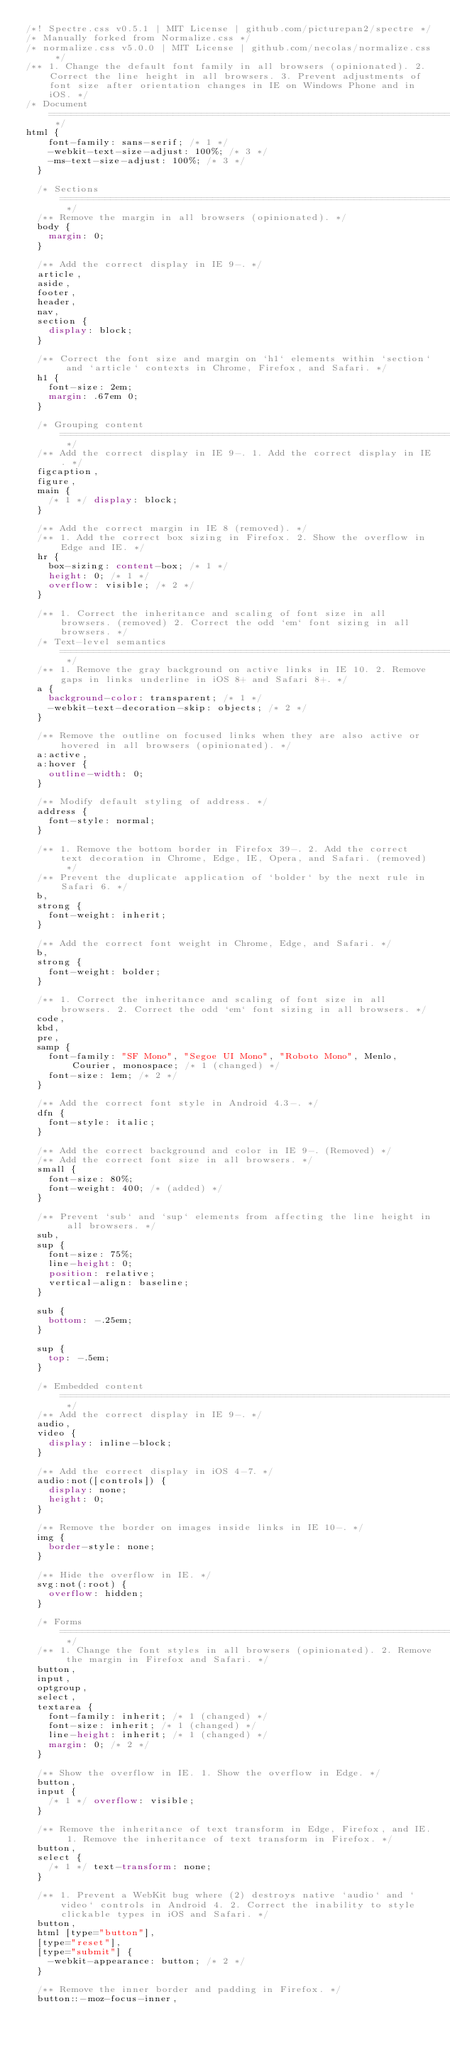Convert code to text. <code><loc_0><loc_0><loc_500><loc_500><_CSS_>/*! Spectre.css v0.5.1 | MIT License | github.com/picturepan2/spectre */
/* Manually forked from Normalize.css */
/* normalize.css v5.0.0 | MIT License | github.com/necolas/normalize.css */
/** 1. Change the default font family in all browsers (opinionated). 2. Correct the line height in all browsers. 3. Prevent adjustments of font size after orientation changes in IE on Windows Phone and in iOS. */
/* Document ========================================================================== */
html {
    font-family: sans-serif; /* 1 */
    -webkit-text-size-adjust: 100%; /* 3 */ 
    -ms-text-size-adjust: 100%; /* 3 */
  }
  
  /* Sections ========================================================================== */
  /** Remove the margin in all browsers (opinionated). */
  body {
    margin: 0;
  }
  
  /** Add the correct display in IE 9-. */
  article,
  aside,
  footer,
  header,
  nav,
  section {
    display: block;
  }
  
  /** Correct the font size and margin on `h1` elements within `section` and `article` contexts in Chrome, Firefox, and Safari. */
  h1 {
    font-size: 2em;
    margin: .67em 0;
  }
  
  /* Grouping content ========================================================================== */
  /** Add the correct display in IE 9-. 1. Add the correct display in IE. */
  figcaption,
  figure,
  main {
    /* 1 */ display: block;
  }
  
  /** Add the correct margin in IE 8 (removed). */
  /** 1. Add the correct box sizing in Firefox. 2. Show the overflow in Edge and IE. */
  hr {
    box-sizing: content-box; /* 1 */
    height: 0; /* 1 */
    overflow: visible; /* 2 */
  }
  
  /** 1. Correct the inheritance and scaling of font size in all browsers. (removed) 2. Correct the odd `em` font sizing in all browsers. */
  /* Text-level semantics ========================================================================== */
  /** 1. Remove the gray background on active links in IE 10. 2. Remove gaps in links underline in iOS 8+ and Safari 8+. */
  a {
    background-color: transparent; /* 1 */
    -webkit-text-decoration-skip: objects; /* 2 */
  }
  
  /** Remove the outline on focused links when they are also active or hovered in all browsers (opinionated). */
  a:active,
  a:hover {
    outline-width: 0;
  }
  
  /** Modify default styling of address. */
  address {
    font-style: normal;
  }
  
  /** 1. Remove the bottom border in Firefox 39-. 2. Add the correct text decoration in Chrome, Edge, IE, Opera, and Safari. (removed) */
  /** Prevent the duplicate application of `bolder` by the next rule in Safari 6. */
  b,
  strong {
    font-weight: inherit;
  }
  
  /** Add the correct font weight in Chrome, Edge, and Safari. */
  b,
  strong {
    font-weight: bolder;
  }
  
  /** 1. Correct the inheritance and scaling of font size in all browsers. 2. Correct the odd `em` font sizing in all browsers. */
  code,
  kbd,
  pre,
  samp {
    font-family: "SF Mono", "Segoe UI Mono", "Roboto Mono", Menlo, Courier, monospace; /* 1 (changed) */
    font-size: 1em; /* 2 */
  }
  
  /** Add the correct font style in Android 4.3-. */
  dfn {
    font-style: italic;
  }
  
  /** Add the correct background and color in IE 9-. (Removed) */
  /** Add the correct font size in all browsers. */
  small {
    font-size: 80%;
    font-weight: 400; /* (added) */
  }
  
  /** Prevent `sub` and `sup` elements from affecting the line height in all browsers. */
  sub,
  sup {
    font-size: 75%;
    line-height: 0;
    position: relative;
    vertical-align: baseline;
  }
  
  sub {
    bottom: -.25em;
  }
  
  sup {
    top: -.5em;
  }
  
  /* Embedded content ========================================================================== */
  /** Add the correct display in IE 9-. */
  audio,
  video {
    display: inline-block;
  }
  
  /** Add the correct display in iOS 4-7. */
  audio:not([controls]) {
    display: none;
    height: 0;
  }
  
  /** Remove the border on images inside links in IE 10-. */
  img {
    border-style: none;
  }
  
  /** Hide the overflow in IE. */
  svg:not(:root) {
    overflow: hidden;
  }
  
  /* Forms ========================================================================== */
  /** 1. Change the font styles in all browsers (opinionated). 2. Remove the margin in Firefox and Safari. */
  button,
  input,
  optgroup,
  select,
  textarea {
    font-family: inherit; /* 1 (changed) */
    font-size: inherit; /* 1 (changed) */
    line-height: inherit; /* 1 (changed) */
    margin: 0; /* 2 */
  }
  
  /** Show the overflow in IE. 1. Show the overflow in Edge. */
  button,
  input {
    /* 1 */ overflow: visible;
  }
  
  /** Remove the inheritance of text transform in Edge, Firefox, and IE. 1. Remove the inheritance of text transform in Firefox. */
  button,
  select {
    /* 1 */ text-transform: none;
  }
  
  /** 1. Prevent a WebKit bug where (2) destroys native `audio` and `video` controls in Android 4. 2. Correct the inability to style clickable types in iOS and Safari. */
  button,
  html [type="button"],
  [type="reset"],
  [type="submit"] {
    -webkit-appearance: button; /* 2 */
  }
  
  /** Remove the inner border and padding in Firefox. */
  button::-moz-focus-inner,</code> 